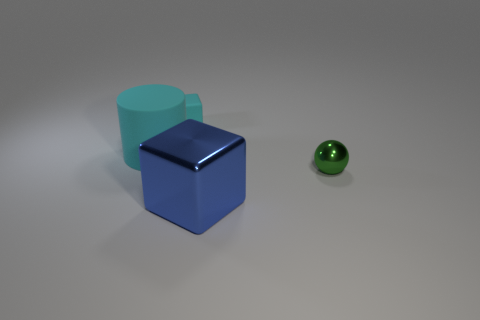Add 3 large blue shiny cubes. How many objects exist? 7 Subtract all cylinders. How many objects are left? 3 Subtract 1 blue blocks. How many objects are left? 3 Subtract all small green metal balls. Subtract all yellow rubber objects. How many objects are left? 3 Add 1 cyan rubber cubes. How many cyan rubber cubes are left? 2 Add 1 big cyan rubber cylinders. How many big cyan rubber cylinders exist? 2 